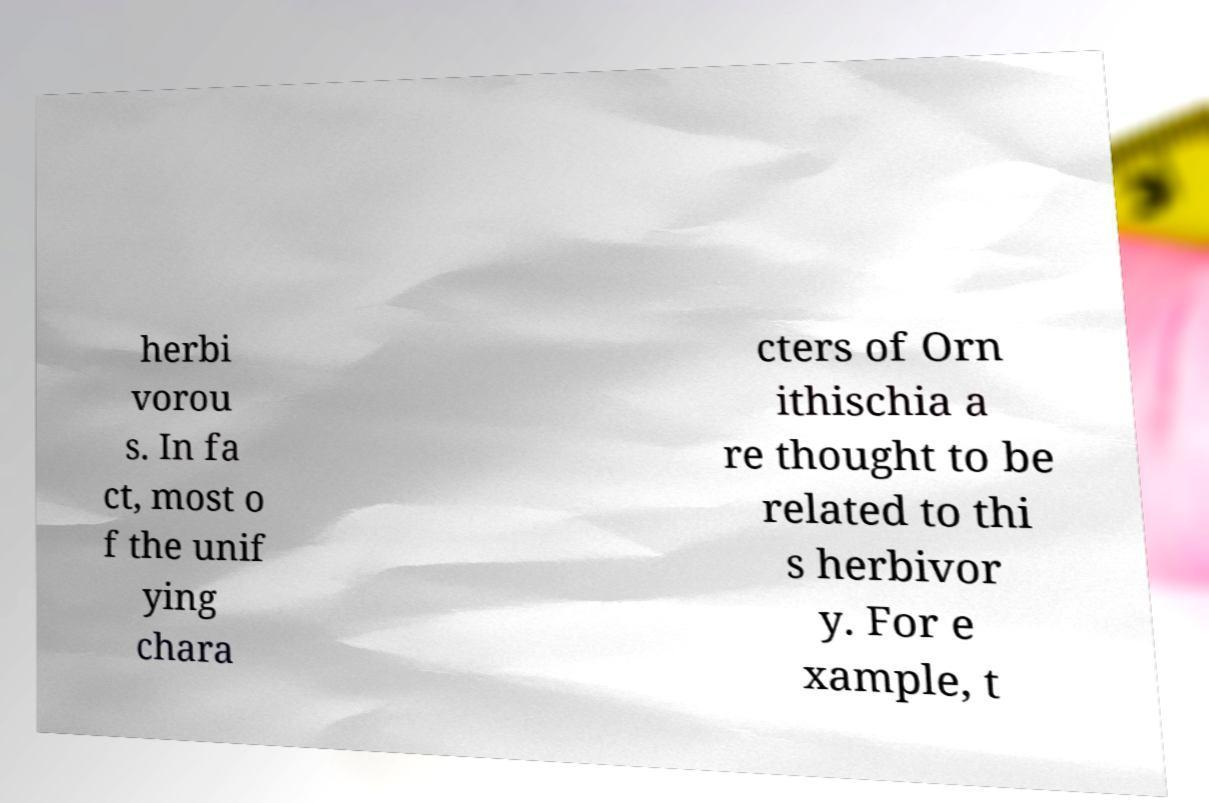What messages or text are displayed in this image? I need them in a readable, typed format. herbi vorou s. In fa ct, most o f the unif ying chara cters of Orn ithischia a re thought to be related to thi s herbivor y. For e xample, t 